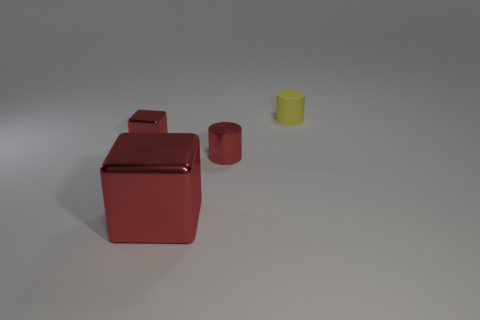Add 1 small red metal things. How many objects exist? 5 Subtract all red cylinders. How many cylinders are left? 1 Subtract 1 cubes. How many cubes are left? 1 Subtract all purple cylinders. Subtract all cyan spheres. How many cylinders are left? 2 Subtract all metal cylinders. Subtract all red metal blocks. How many objects are left? 1 Add 4 red metal cubes. How many red metal cubes are left? 6 Add 1 yellow things. How many yellow things exist? 2 Subtract 0 green cubes. How many objects are left? 4 